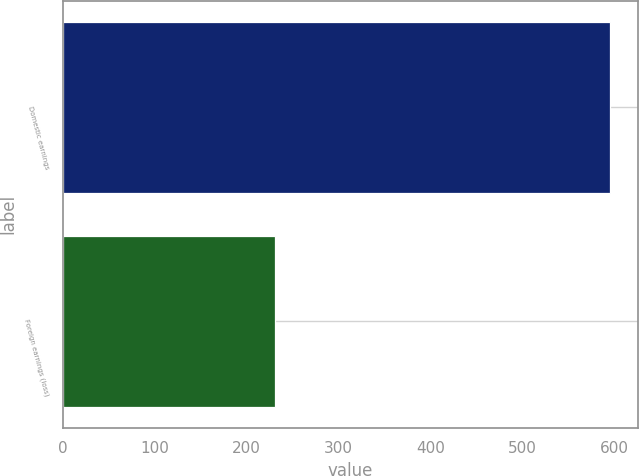Convert chart. <chart><loc_0><loc_0><loc_500><loc_500><bar_chart><fcel>Domestic earnings<fcel>Foreign earnings (loss)<nl><fcel>595<fcel>231<nl></chart> 